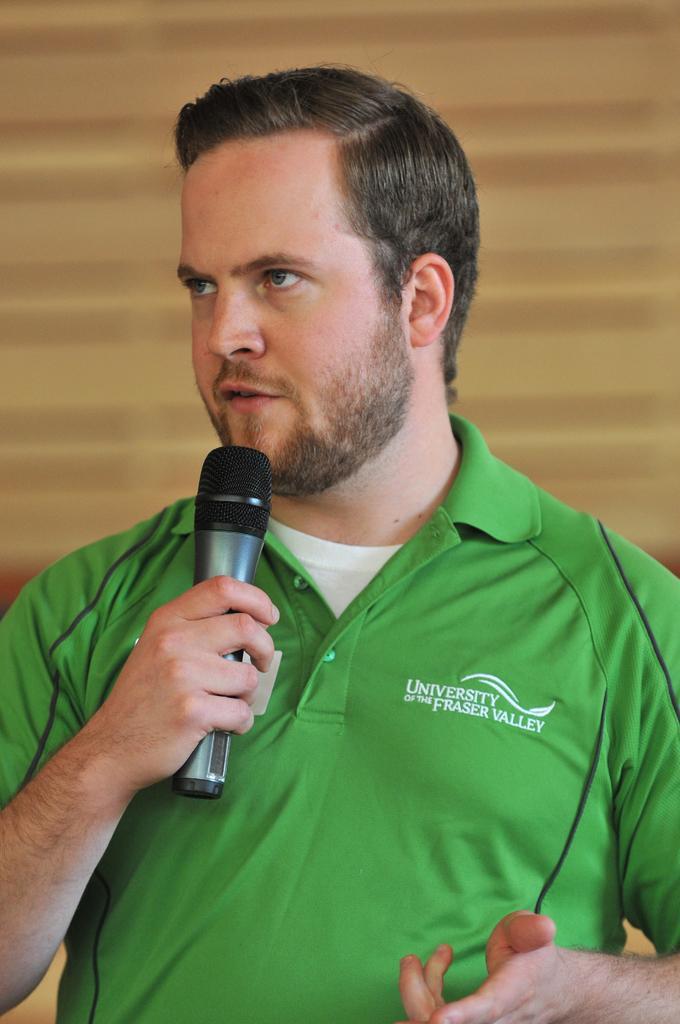Can you describe this image briefly? In this picture there is a boy at the center of the image by holding a mic in his hand. 